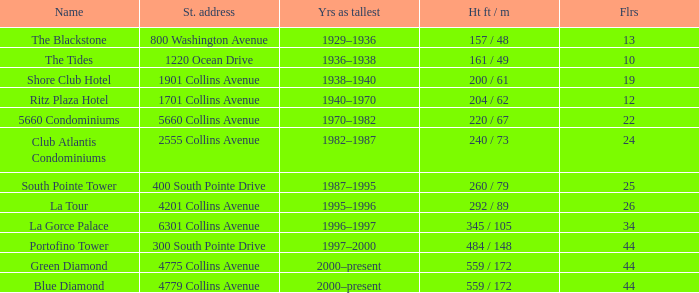How many years was the building with 24 floors the tallest? 1982–1987. 